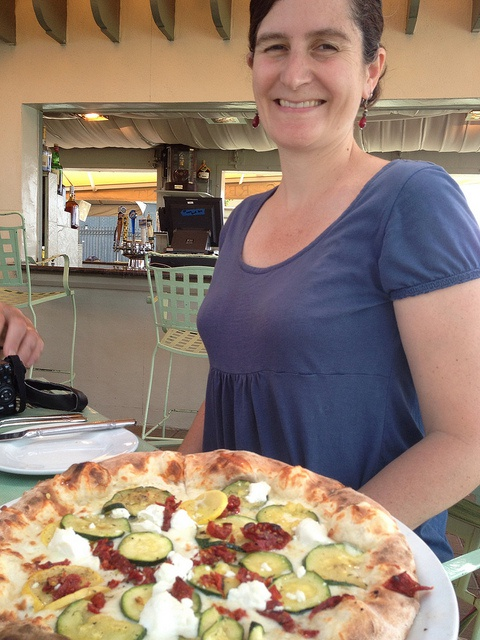Describe the objects in this image and their specific colors. I can see people in maroon, gray, tan, navy, and darkblue tones, pizza in maroon, tan, and ivory tones, chair in maroon, gray, and darkgray tones, chair in maroon and gray tones, and people in maroon, gray, and salmon tones in this image. 